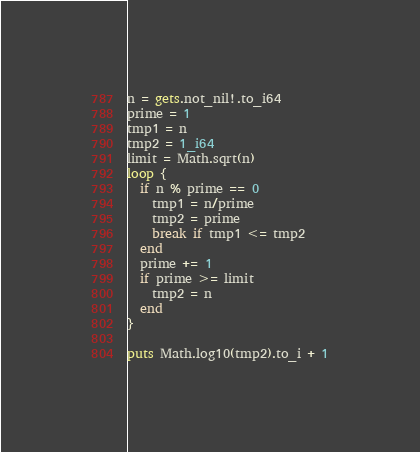<code> <loc_0><loc_0><loc_500><loc_500><_Crystal_>n = gets.not_nil!.to_i64
prime = 1
tmp1 = n
tmp2 = 1_i64
limit = Math.sqrt(n)
loop {
  if n % prime == 0
    tmp1 = n/prime
    tmp2 = prime
    break if tmp1 <= tmp2
  end
  prime += 1
  if prime >= limit
    tmp2 = n
  end
}

puts Math.log10(tmp2).to_i + 1
</code> 